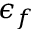<formula> <loc_0><loc_0><loc_500><loc_500>\epsilon _ { f }</formula> 